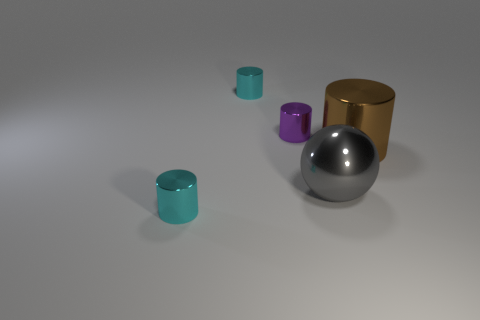How can the lighting in this scene contribute to its mood? The soft and evenly distributed lighting in this scene creates a calm and unassuming mood. There are no harsh shadows or bright highlights, producing a feeling of neutrality and objectivity as if we're invited to observe and reflect on the objects without emotional interference. 